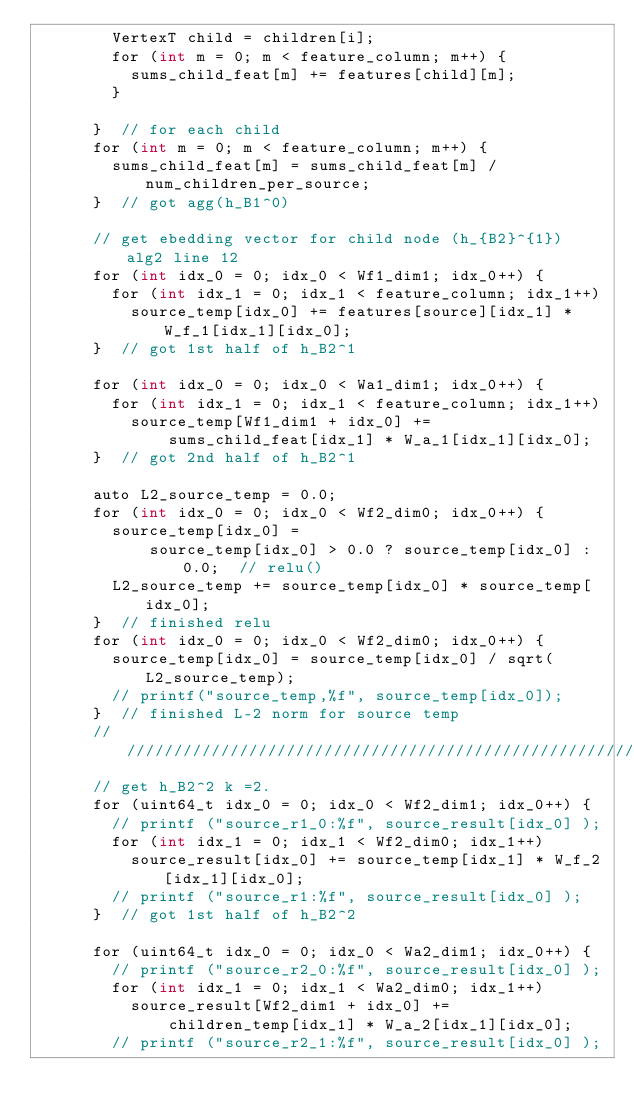<code> <loc_0><loc_0><loc_500><loc_500><_Cuda_>        VertexT child = children[i];
        for (int m = 0; m < feature_column; m++) {
          sums_child_feat[m] += features[child][m];
        }

      }  // for each child
      for (int m = 0; m < feature_column; m++) {
        sums_child_feat[m] = sums_child_feat[m] / num_children_per_source;
      }  // got agg(h_B1^0)

      // get ebedding vector for child node (h_{B2}^{1}) alg2 line 12
      for (int idx_0 = 0; idx_0 < Wf1_dim1; idx_0++) {
        for (int idx_1 = 0; idx_1 < feature_column; idx_1++)
          source_temp[idx_0] += features[source][idx_1] * W_f_1[idx_1][idx_0];
      }  // got 1st half of h_B2^1

      for (int idx_0 = 0; idx_0 < Wa1_dim1; idx_0++) {
        for (int idx_1 = 0; idx_1 < feature_column; idx_1++)
          source_temp[Wf1_dim1 + idx_0] +=
              sums_child_feat[idx_1] * W_a_1[idx_1][idx_0];
      }  // got 2nd half of h_B2^1

      auto L2_source_temp = 0.0;
      for (int idx_0 = 0; idx_0 < Wf2_dim0; idx_0++) {
        source_temp[idx_0] =
            source_temp[idx_0] > 0.0 ? source_temp[idx_0] : 0.0;  // relu()
        L2_source_temp += source_temp[idx_0] * source_temp[idx_0];
      }  // finished relu
      for (int idx_0 = 0; idx_0 < Wf2_dim0; idx_0++) {
        source_temp[idx_0] = source_temp[idx_0] / sqrt(L2_source_temp);
        // printf("source_temp,%f", source_temp[idx_0]);
      }  // finished L-2 norm for source temp
      //////////////////////////////////////////////////////////////////////////////////////
      // get h_B2^2 k =2.
      for (uint64_t idx_0 = 0; idx_0 < Wf2_dim1; idx_0++) {
        // printf ("source_r1_0:%f", source_result[idx_0] );
        for (int idx_1 = 0; idx_1 < Wf2_dim0; idx_1++)
          source_result[idx_0] += source_temp[idx_1] * W_f_2[idx_1][idx_0];
        // printf ("source_r1:%f", source_result[idx_0] );
      }  // got 1st half of h_B2^2

      for (uint64_t idx_0 = 0; idx_0 < Wa2_dim1; idx_0++) {
        // printf ("source_r2_0:%f", source_result[idx_0] );
        for (int idx_1 = 0; idx_1 < Wa2_dim0; idx_1++)
          source_result[Wf2_dim1 + idx_0] +=
              children_temp[idx_1] * W_a_2[idx_1][idx_0];
        // printf ("source_r2_1:%f", source_result[idx_0] );
</code> 